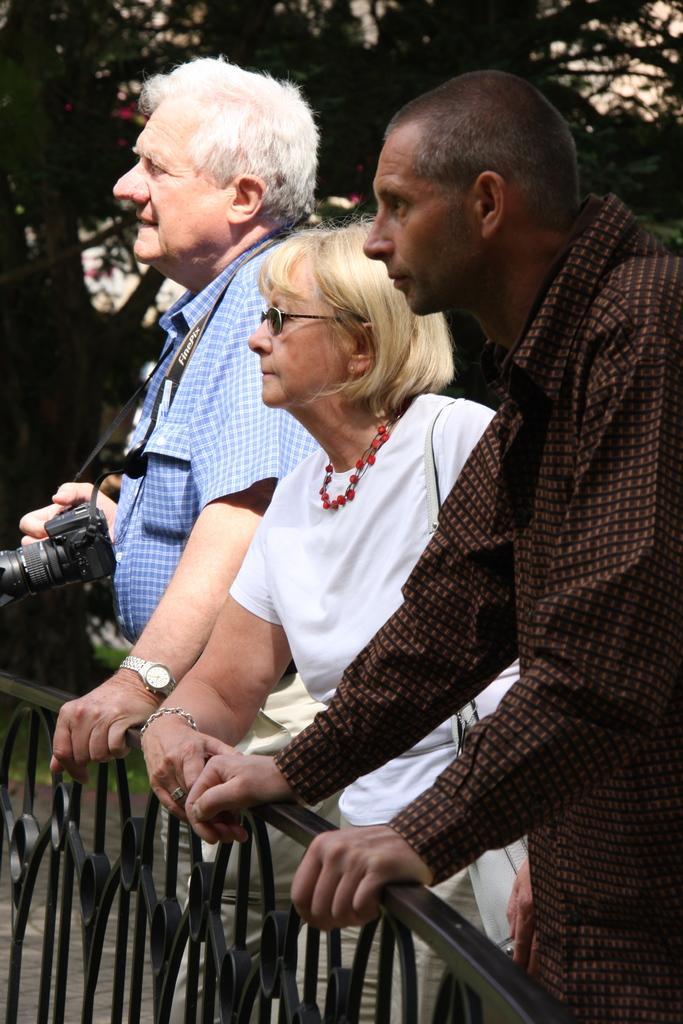Please provide a concise description of this image. There are three persons. They are standing and they are holding a bridge wall. On the left side we have a person. He's holding a camera. 